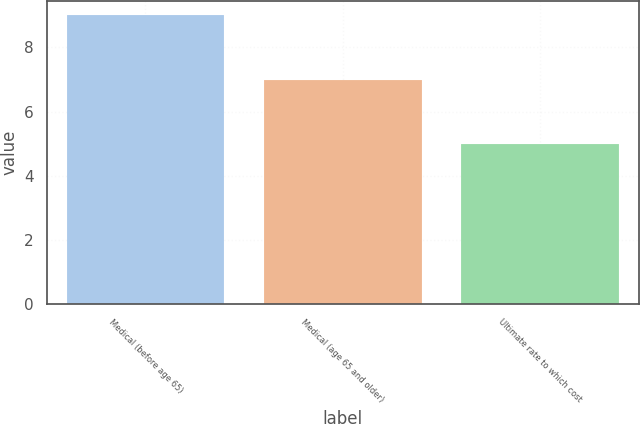<chart> <loc_0><loc_0><loc_500><loc_500><bar_chart><fcel>Medical (before age 65)<fcel>Medical (age 65 and older)<fcel>Ultimate rate to which cost<nl><fcel>9<fcel>7<fcel>5<nl></chart> 